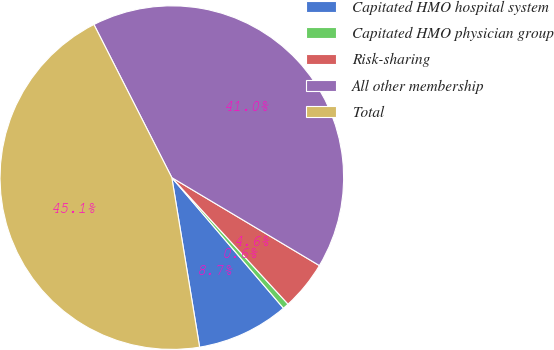Convert chart to OTSL. <chart><loc_0><loc_0><loc_500><loc_500><pie_chart><fcel>Capitated HMO hospital system<fcel>Capitated HMO physician group<fcel>Risk-sharing<fcel>All other membership<fcel>Total<nl><fcel>8.67%<fcel>0.57%<fcel>4.62%<fcel>41.05%<fcel>45.1%<nl></chart> 